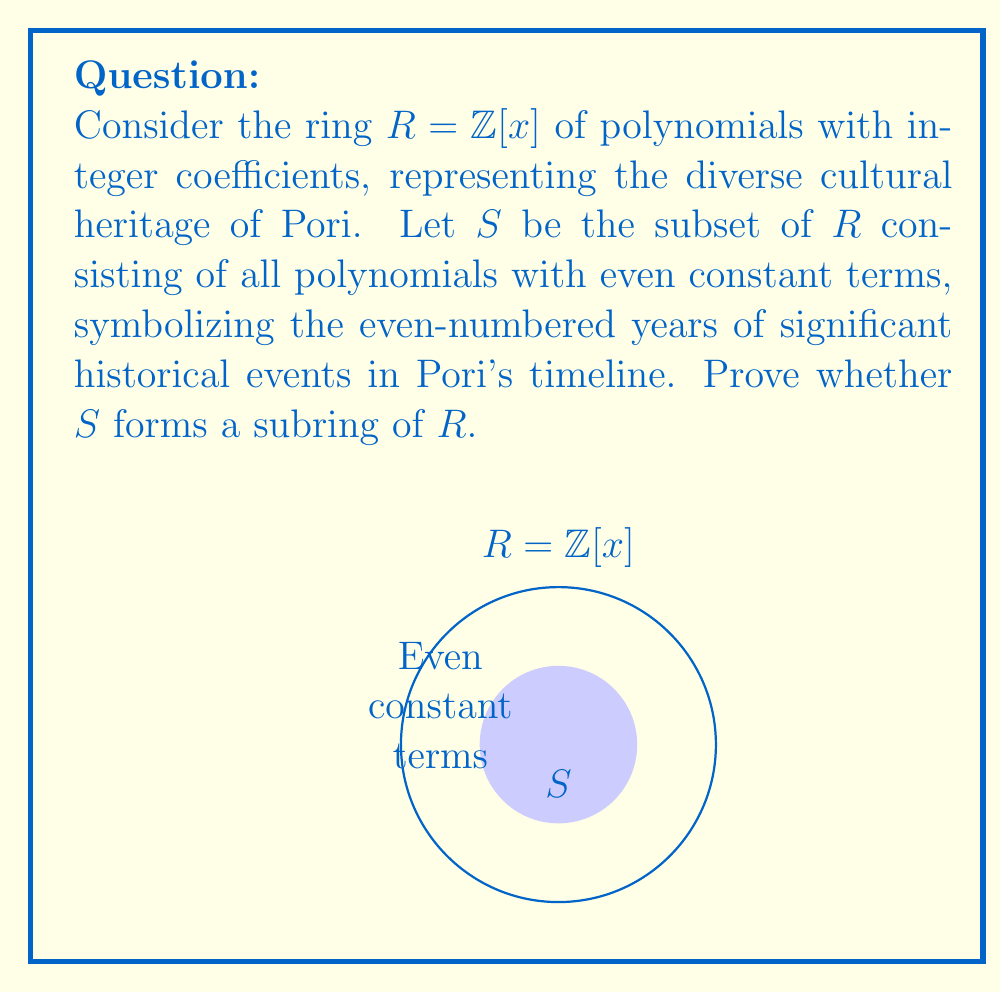Solve this math problem. To prove that $S$ is a subring of $R$, we need to show that it satisfies three conditions:

1. Closure under addition: Let $f(x), g(x) \in S$. Then:
   $f(x) = a_nx^n + ... + a_1x + 2k$
   $g(x) = b_mx^m + ... + b_1x + 2l$
   where $k, l \in \mathbb{Z}$.
   $f(x) + g(x) = (a_nx^n + ... + a_1x + 2k) + (b_mx^m + ... + b_1x + 2l)$
   $= (a_n+b_n)x^n + ... + (a_1+b_1)x + (2k+2l)$
   $= (a_n+b_n)x^n + ... + (a_1+b_1)x + 2(k+l)$
   The constant term $2(k+l)$ is even, so $f(x) + g(x) \in S$.

2. Closure under multiplication: Let $f(x), g(x) \in S$. Then:
   $f(x)g(x) = (a_nx^n + ... + a_1x + 2k)(b_mx^m + ... + b_1x + 2l)$
   $= a_nb_mx^{n+m} + ... + (2ka_1 + 2la_1)x + 4kl$
   The constant term $4kl$ is even, so $f(x)g(x) \in S$.

3. Existence of additive inverse: For any $f(x) = a_nx^n + ... + a_1x + 2k \in S$,
   $-f(x) = -a_nx^n - ... - a_1x - 2k \in S$ since $-2k$ is even.

Therefore, $S$ satisfies all three conditions and forms a subring of $R$.
Answer: $S$ is a subring of $R$. 